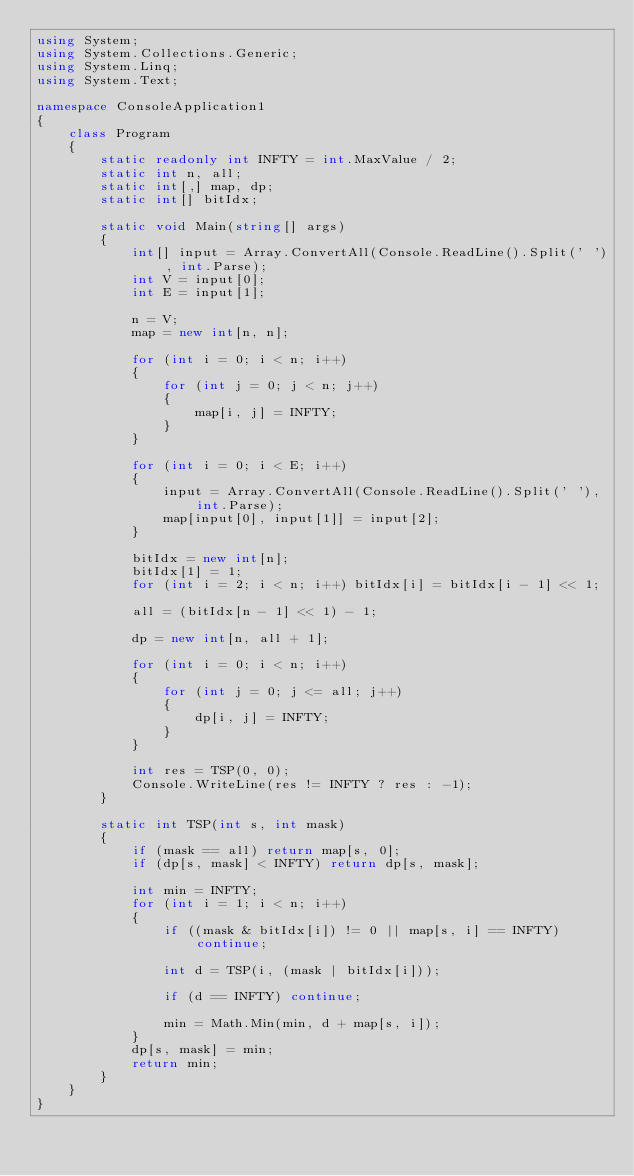<code> <loc_0><loc_0><loc_500><loc_500><_C#_>using System;
using System.Collections.Generic;
using System.Linq;
using System.Text;

namespace ConsoleApplication1
{
    class Program
    {
        static readonly int INFTY = int.MaxValue / 2;
        static int n, all;
        static int[,] map, dp;
        static int[] bitIdx;

        static void Main(string[] args)
        {
            int[] input = Array.ConvertAll(Console.ReadLine().Split(' '), int.Parse);
            int V = input[0];
            int E = input[1];

            n = V;
            map = new int[n, n];

            for (int i = 0; i < n; i++)
            {
                for (int j = 0; j < n; j++)
                {
                    map[i, j] = INFTY;
                }
            }

            for (int i = 0; i < E; i++)
            {
                input = Array.ConvertAll(Console.ReadLine().Split(' '), int.Parse);
                map[input[0], input[1]] = input[2];
            }

            bitIdx = new int[n];
            bitIdx[1] = 1;
            for (int i = 2; i < n; i++) bitIdx[i] = bitIdx[i - 1] << 1;

            all = (bitIdx[n - 1] << 1) - 1;

            dp = new int[n, all + 1];

            for (int i = 0; i < n; i++)
            {
                for (int j = 0; j <= all; j++)
                {
                    dp[i, j] = INFTY;
                }
            }

            int res = TSP(0, 0);
            Console.WriteLine(res != INFTY ? res : -1);
        }

        static int TSP(int s, int mask)
        {
            if (mask == all) return map[s, 0];
            if (dp[s, mask] < INFTY) return dp[s, mask];

            int min = INFTY;
            for (int i = 1; i < n; i++)
            {
                if ((mask & bitIdx[i]) != 0 || map[s, i] == INFTY) continue;

                int d = TSP(i, (mask | bitIdx[i]));

                if (d == INFTY) continue;

                min = Math.Min(min, d + map[s, i]);
            }
            dp[s, mask] = min;
            return min;
        }
    }
}</code> 